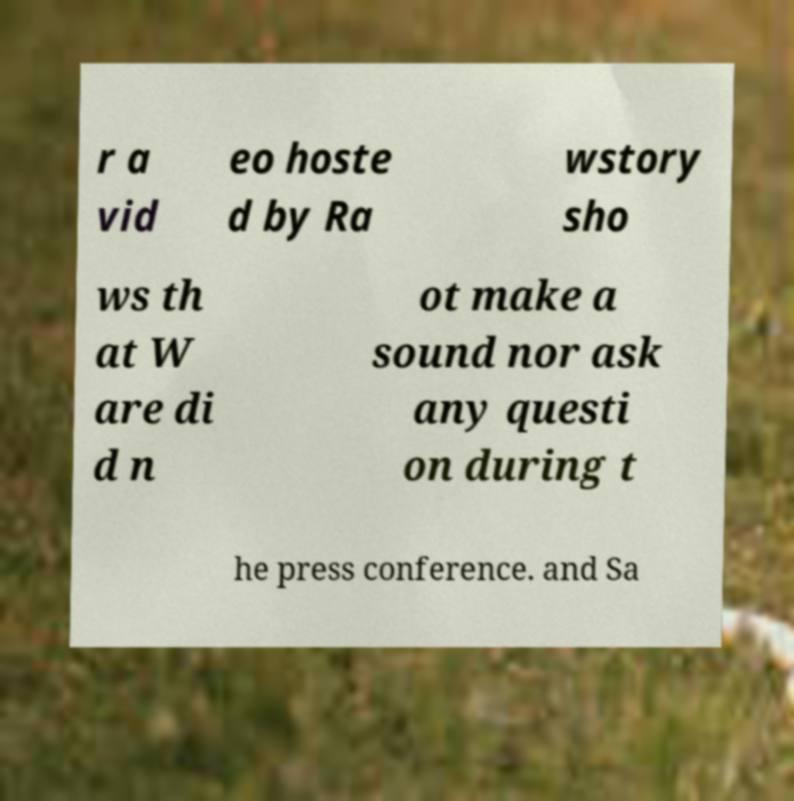Please identify and transcribe the text found in this image. r a vid eo hoste d by Ra wstory sho ws th at W are di d n ot make a sound nor ask any questi on during t he press conference. and Sa 